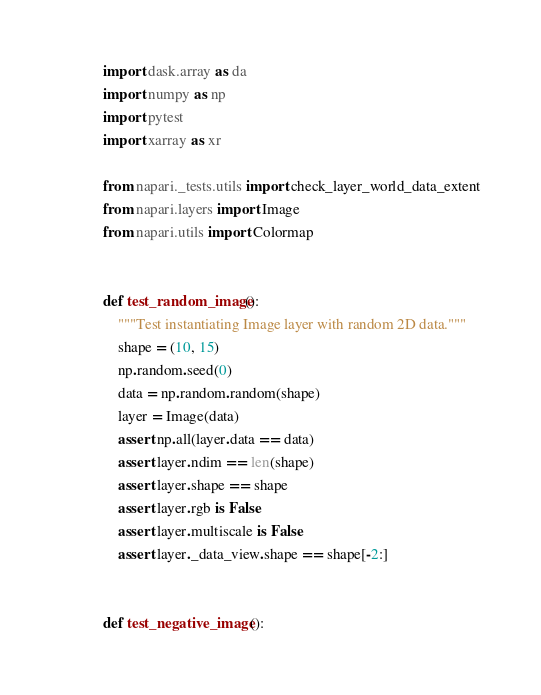Convert code to text. <code><loc_0><loc_0><loc_500><loc_500><_Python_>import dask.array as da
import numpy as np
import pytest
import xarray as xr

from napari._tests.utils import check_layer_world_data_extent
from napari.layers import Image
from napari.utils import Colormap


def test_random_image():
    """Test instantiating Image layer with random 2D data."""
    shape = (10, 15)
    np.random.seed(0)
    data = np.random.random(shape)
    layer = Image(data)
    assert np.all(layer.data == data)
    assert layer.ndim == len(shape)
    assert layer.shape == shape
    assert layer.rgb is False
    assert layer.multiscale is False
    assert layer._data_view.shape == shape[-2:]


def test_negative_image():</code> 